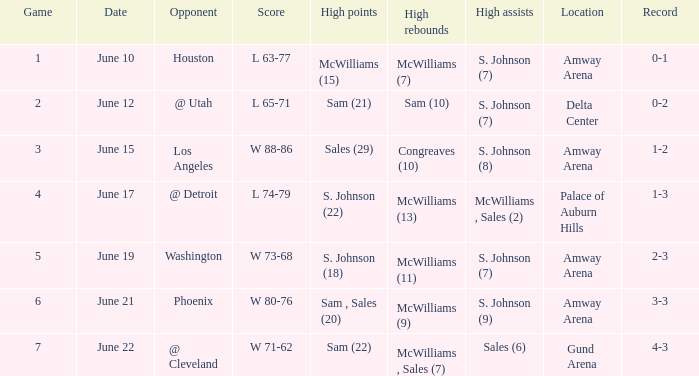Name the total number of date for  l 63-77 1.0. 